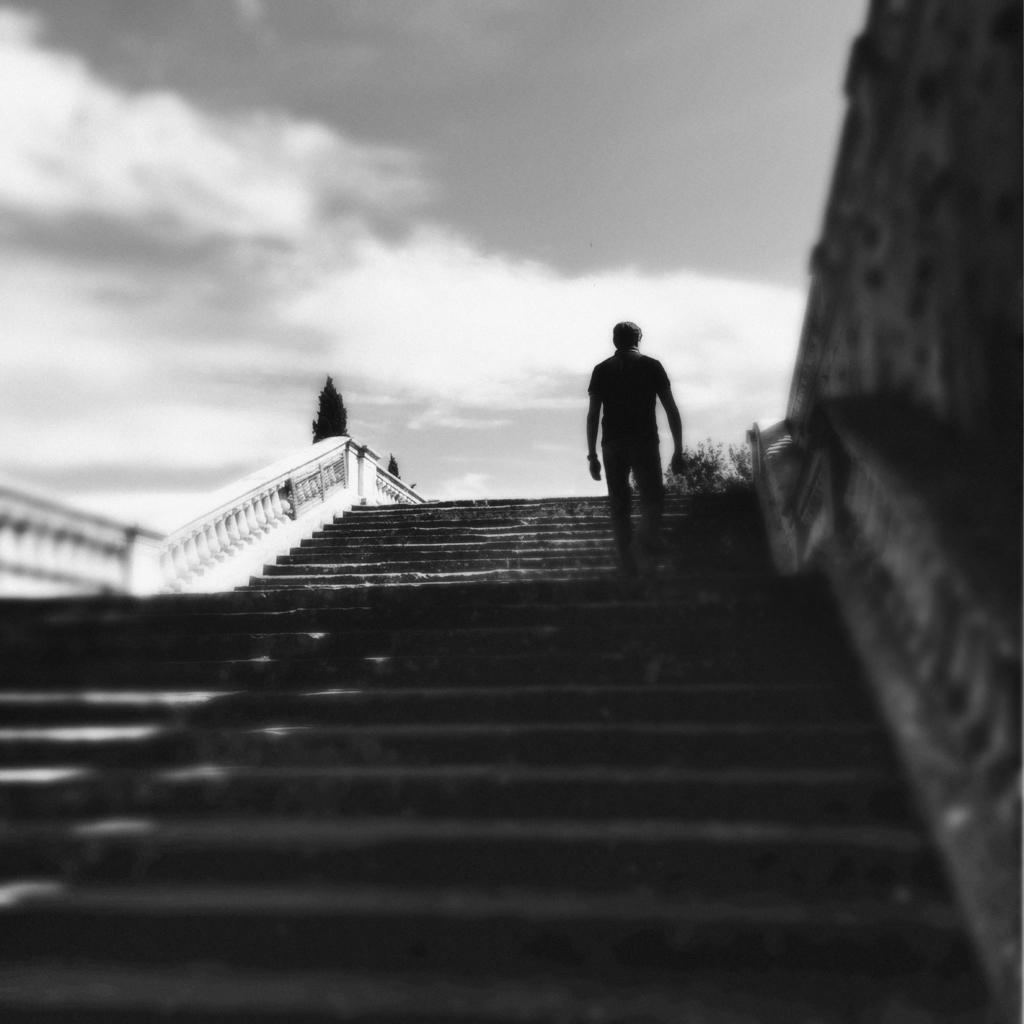Please provide a concise description of this image. In this picture I can see the steps in front and I can see a person standing. In the background I can see the cloudy sky. On the right side of this picture, I can see the wall. 